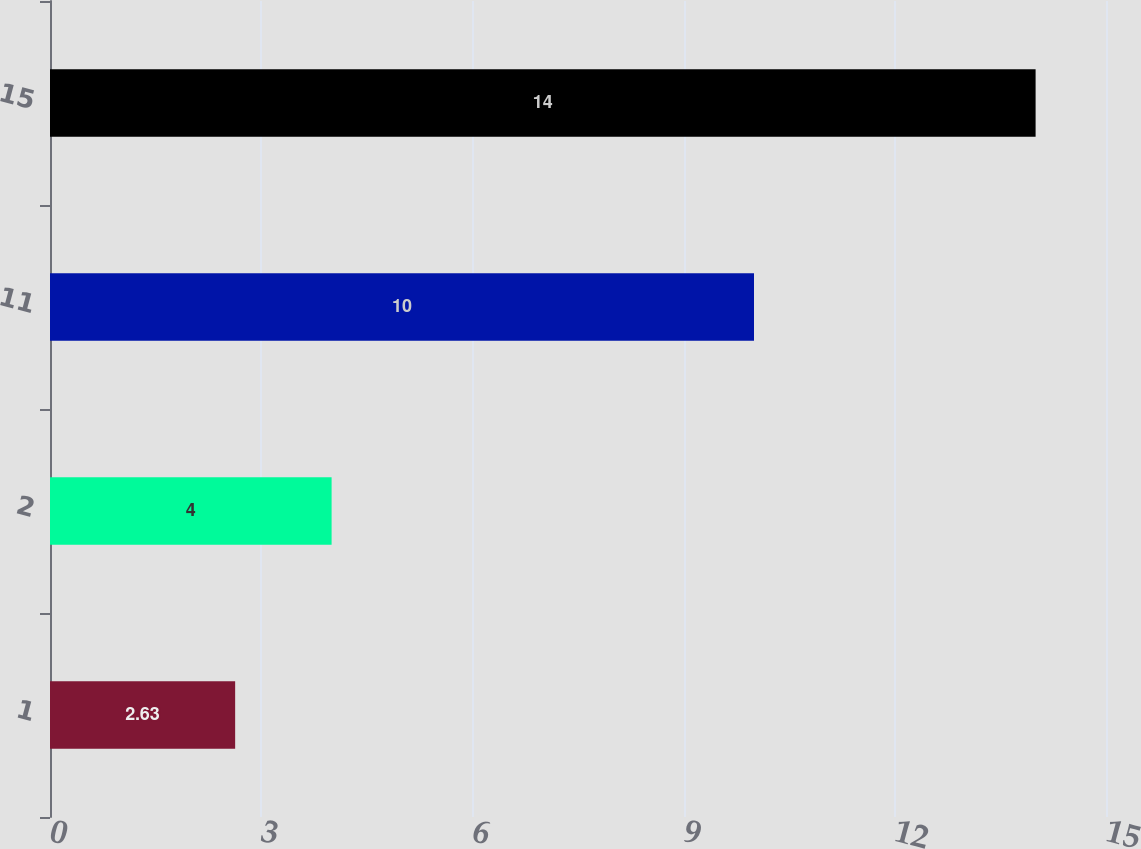<chart> <loc_0><loc_0><loc_500><loc_500><bar_chart><fcel>1<fcel>2<fcel>11<fcel>15<nl><fcel>2.63<fcel>4<fcel>10<fcel>14<nl></chart> 